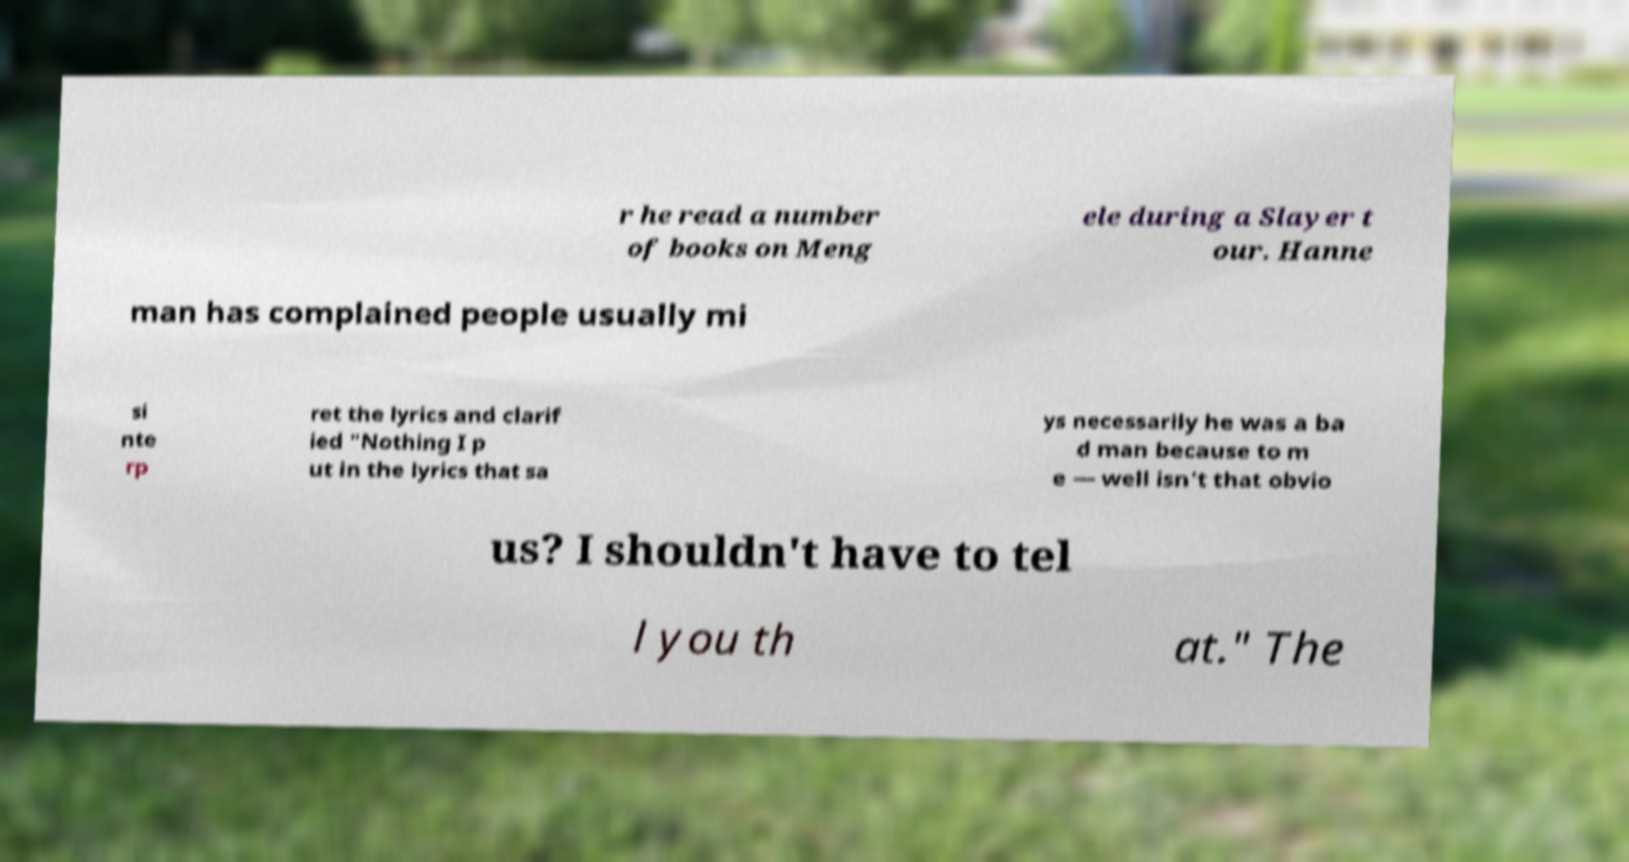Can you read and provide the text displayed in the image?This photo seems to have some interesting text. Can you extract and type it out for me? r he read a number of books on Meng ele during a Slayer t our. Hanne man has complained people usually mi si nte rp ret the lyrics and clarif ied "Nothing I p ut in the lyrics that sa ys necessarily he was a ba d man because to m e — well isn't that obvio us? I shouldn't have to tel l you th at." The 